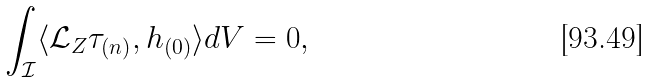Convert formula to latex. <formula><loc_0><loc_0><loc_500><loc_500>\int _ { \mathcal { I } } \langle { \mathcal { L } } _ { Z } \tau _ { ( n ) } , h _ { ( 0 ) } \rangle d V = 0 ,</formula> 